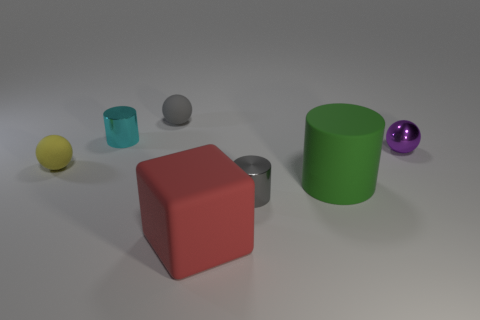Do the small ball on the left side of the small gray matte object and the matte sphere that is right of the yellow matte ball have the same color?
Offer a very short reply. No. There is a metallic cylinder right of the tiny rubber thing that is to the right of the small sphere that is in front of the tiny purple thing; what is its size?
Offer a very short reply. Small. What shape is the thing that is both to the left of the small gray rubber ball and in front of the small cyan object?
Your answer should be very brief. Sphere. Are there an equal number of large green cylinders left of the rubber cube and tiny yellow things that are to the right of the gray matte ball?
Keep it short and to the point. Yes. Is there a tiny object made of the same material as the block?
Make the answer very short. Yes. Is the material of the purple sphere in front of the gray matte thing the same as the green object?
Your answer should be very brief. No. There is a matte object that is both behind the green object and in front of the small purple thing; how big is it?
Make the answer very short. Small. The big rubber cube has what color?
Your answer should be very brief. Red. What number of tiny cyan cubes are there?
Give a very brief answer. 0. There is a gray object that is left of the gray metal thing; does it have the same shape as the thing right of the green cylinder?
Provide a short and direct response. Yes. 